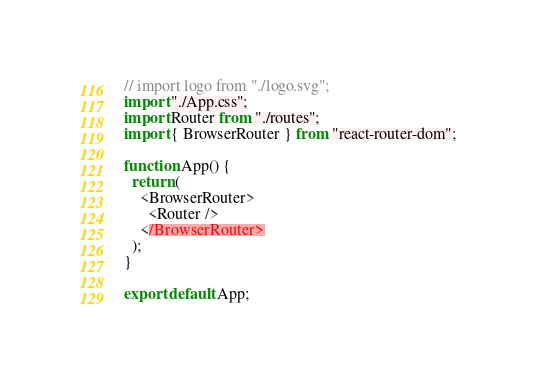<code> <loc_0><loc_0><loc_500><loc_500><_JavaScript_>// import logo from "./logo.svg";
import "./App.css";
import Router from "./routes";
import { BrowserRouter } from "react-router-dom";

function App() {
  return (
    <BrowserRouter>
      <Router />
    </BrowserRouter>
  );
}

export default App;
</code> 